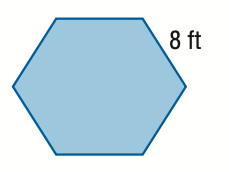Answer the mathemtical geometry problem and directly provide the correct option letter.
Question: Find the area of the regular polygon figure. Round to the nearest tenth.
Choices: A: 27.7 B: 55.4 C: 166.3 D: 332.6 C 